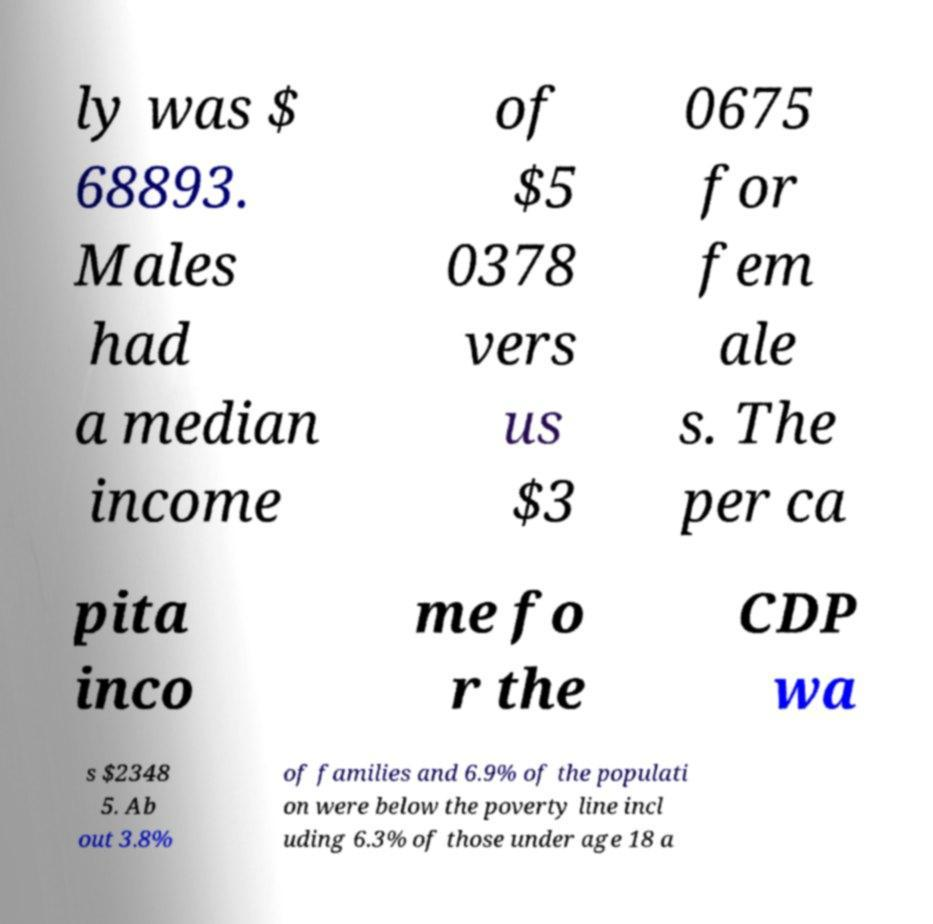I need the written content from this picture converted into text. Can you do that? ly was $ 68893. Males had a median income of $5 0378 vers us $3 0675 for fem ale s. The per ca pita inco me fo r the CDP wa s $2348 5. Ab out 3.8% of families and 6.9% of the populati on were below the poverty line incl uding 6.3% of those under age 18 a 